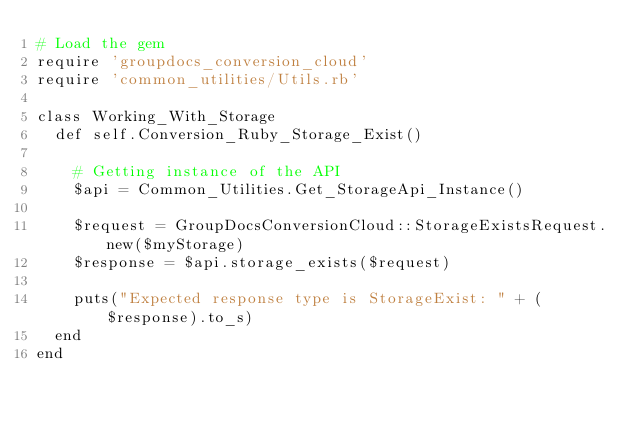Convert code to text. <code><loc_0><loc_0><loc_500><loc_500><_Ruby_># Load the gem
require 'groupdocs_conversion_cloud'
require 'common_utilities/Utils.rb'

class Working_With_Storage
  def self.Conversion_Ruby_Storage_Exist()

    # Getting instance of the API
    $api = Common_Utilities.Get_StorageApi_Instance()
    
    $request = GroupDocsConversionCloud::StorageExistsRequest.new($myStorage)
    $response = $api.storage_exists($request)

    puts("Expected response type is StorageExist: " + ($response).to_s)
  end
end</code> 